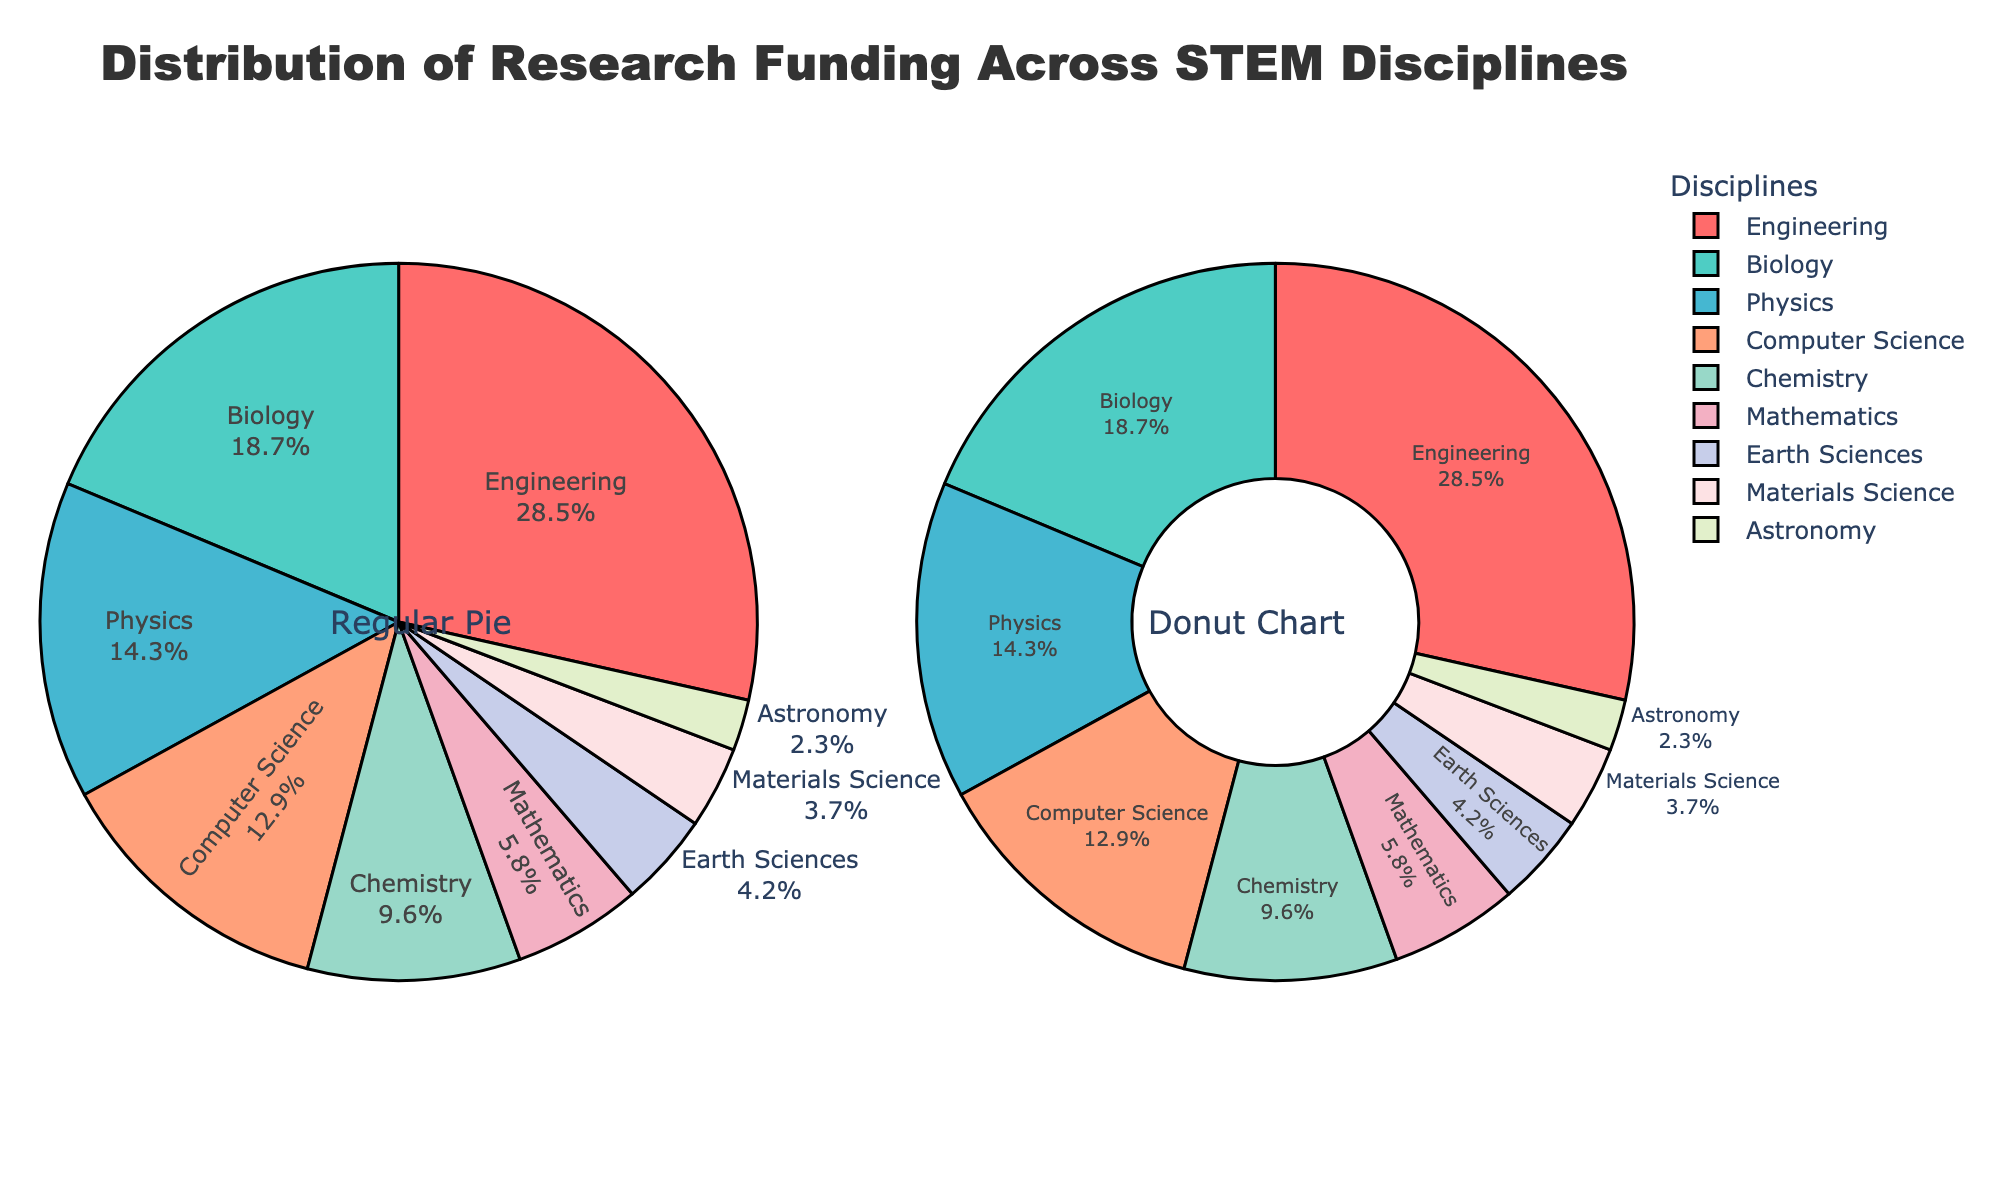What is the funding percentage for Biology in the donut chart? In the donut chart, each discipline's funding percentage is labeled. Locate the label for Biology to find the percentage.
Answer: 18.7% Which discipline receives more funding: Computer Science or Chemistry? Compare the funding percentages for Computer Science (12.9%) and Chemistry (9.6%) as labeled in the chart.
Answer: Computer Science What is the combined funding percentage of Earth Sciences and Materials Science? Add the funding percentages for Earth Sciences (4.2%) and Materials Science (3.7%).
Answer: 7.9% What is the difference in funding percentage between Engineering and Mathematics? Subtract the funding percentage of Mathematics (5.8%) from Engineering (28.5%).
Answer: 22.7% Which discipline is shown in blue in the regular pie chart? Identify the discipline labeled in blue in the regular pie chart.
Answer: Physics Is the funding percentage for Astronomy greater than or less than 3%? Look at the label for Astronomy in both charts; it shows 2.3%.
Answer: Less than What is the total funding percentage for all non-engineering disciplines combined? Subtract Engineering's funding percentage (28.5%) from the total (100%).
Answer: 71.5% What is the average funding percentage of the four disciplines with the lowest funding percentages? Find the average of Astronomy (2.3%), Materials Science (3.7%), Earth Sciences (4.2%), and Mathematics (5.8%): (2.3 + 3.7 + 4.2 + 5.8) / 4.
Answer: 4.0 Which discipline is more funded: Physics or Biology, and by how much? Compare the funding percentages, with Physics at 14.3% and Biology at 18.7%, and calculate the difference.
Answer: Biology by 4.4% Which discipline receives the highest funding percentage? Locate the discipline with the largest slice in either pie chart labeled as Engineering with 28.5%.
Answer: Engineering 